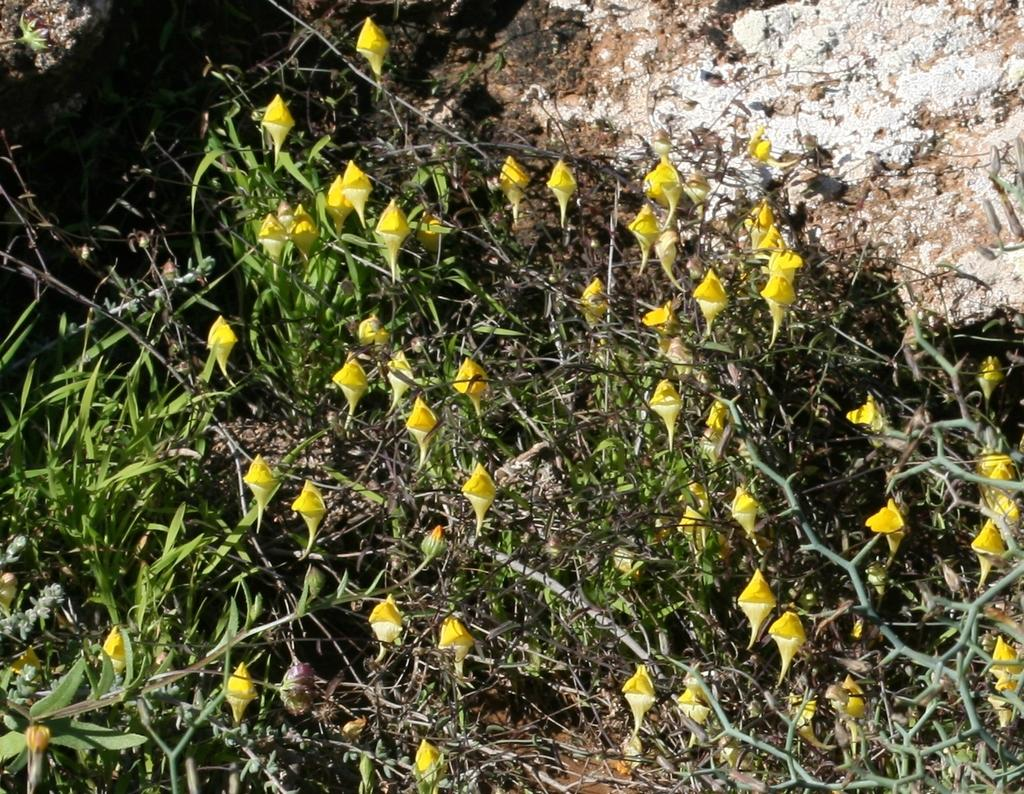What type of plant is in the image? The image contains a plant. What color are the leaves of the plant? The plant has green leaves. What color are the flowers of the plant? The plant has yellow flowers. How many friends can be seen singing a song in the image? There are no friends or singing in the image; it features a plant with green leaves and yellow flowers. 